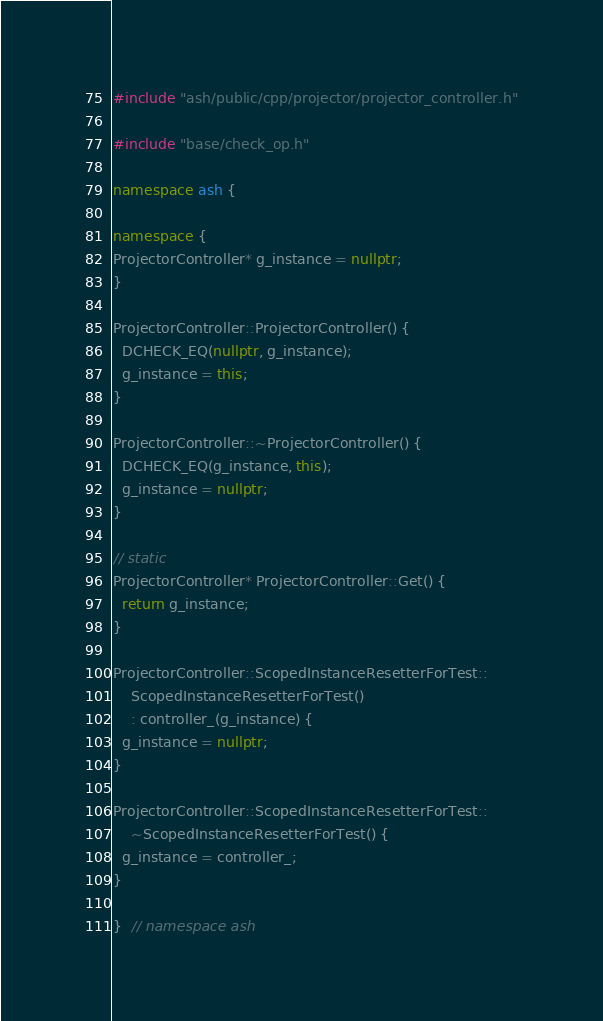Convert code to text. <code><loc_0><loc_0><loc_500><loc_500><_C++_>
#include "ash/public/cpp/projector/projector_controller.h"

#include "base/check_op.h"

namespace ash {

namespace {
ProjectorController* g_instance = nullptr;
}

ProjectorController::ProjectorController() {
  DCHECK_EQ(nullptr, g_instance);
  g_instance = this;
}

ProjectorController::~ProjectorController() {
  DCHECK_EQ(g_instance, this);
  g_instance = nullptr;
}

// static
ProjectorController* ProjectorController::Get() {
  return g_instance;
}

ProjectorController::ScopedInstanceResetterForTest::
    ScopedInstanceResetterForTest()
    : controller_(g_instance) {
  g_instance = nullptr;
}

ProjectorController::ScopedInstanceResetterForTest::
    ~ScopedInstanceResetterForTest() {
  g_instance = controller_;
}

}  // namespace ash
</code> 